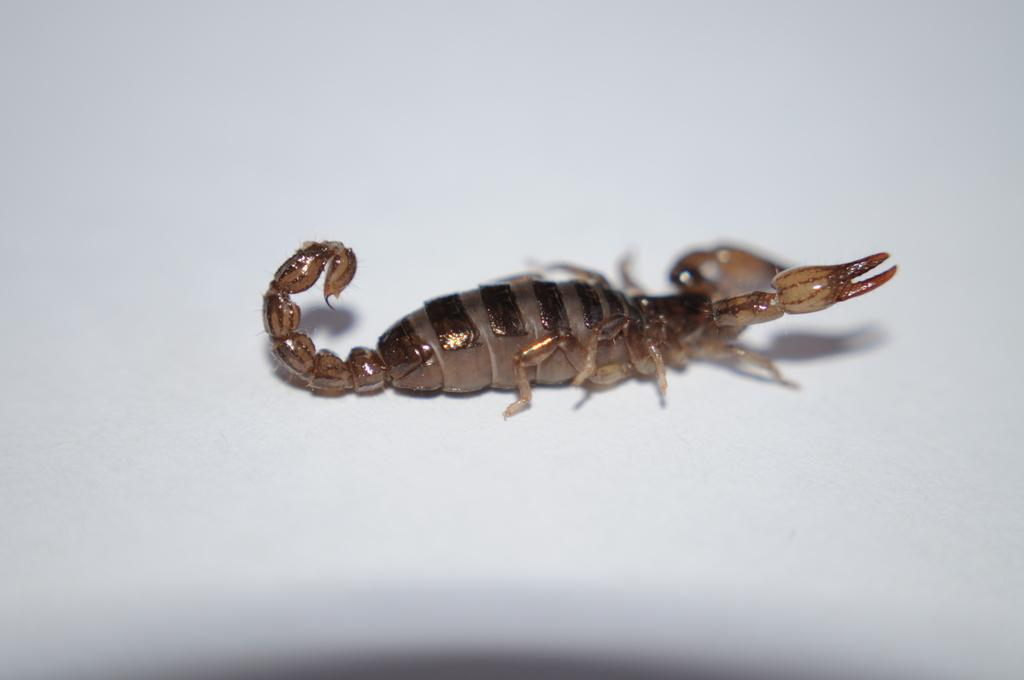What type of animal is in the image? There is a scorpion in the image. What is the color of the surface the scorpion is on? The scorpion is on a white surface. What word is the scorpion trying to spell with its legs in the image? There is no indication in the image that the scorpion is trying to spell any word with its legs. 